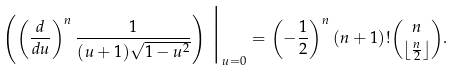Convert formula to latex. <formula><loc_0><loc_0><loc_500><loc_500>\left ( \left ( \frac { d } { d u } \right ) ^ { n } \frac { 1 } { ( u + 1 ) \sqrt { 1 - u ^ { 2 } } } \right ) \, \Big | _ { u = 0 } = \left ( - \frac { 1 } { 2 } \right ) ^ { n } ( n + 1 ) ! \binom { n } { \left \lfloor \frac { n } { 2 } \right \rfloor } .</formula> 